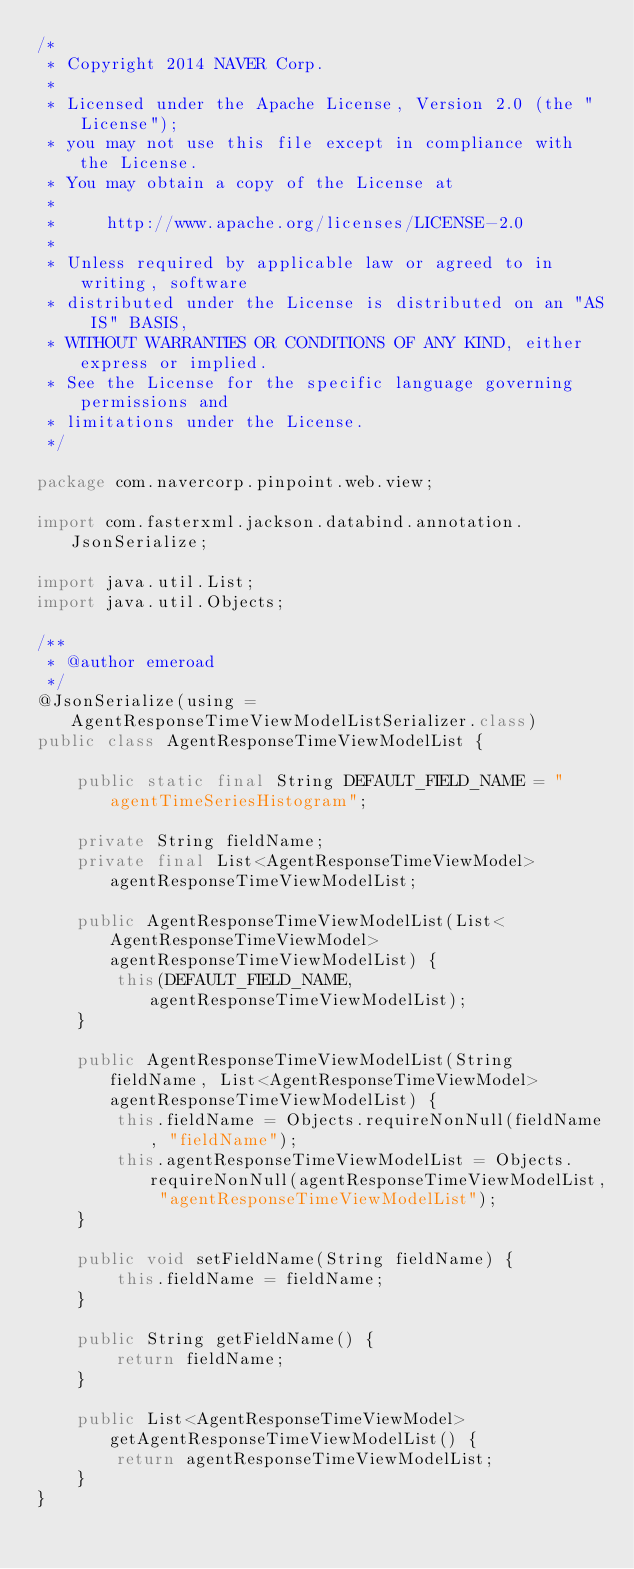Convert code to text. <code><loc_0><loc_0><loc_500><loc_500><_Java_>/*
 * Copyright 2014 NAVER Corp.
 *
 * Licensed under the Apache License, Version 2.0 (the "License");
 * you may not use this file except in compliance with the License.
 * You may obtain a copy of the License at
 *
 *     http://www.apache.org/licenses/LICENSE-2.0
 *
 * Unless required by applicable law or agreed to in writing, software
 * distributed under the License is distributed on an "AS IS" BASIS,
 * WITHOUT WARRANTIES OR CONDITIONS OF ANY KIND, either express or implied.
 * See the License for the specific language governing permissions and
 * limitations under the License.
 */

package com.navercorp.pinpoint.web.view;

import com.fasterxml.jackson.databind.annotation.JsonSerialize;

import java.util.List;
import java.util.Objects;

/**
 * @author emeroad
 */
@JsonSerialize(using = AgentResponseTimeViewModelListSerializer.class)
public class AgentResponseTimeViewModelList {

    public static final String DEFAULT_FIELD_NAME = "agentTimeSeriesHistogram";

    private String fieldName;
    private final List<AgentResponseTimeViewModel> agentResponseTimeViewModelList;

    public AgentResponseTimeViewModelList(List<AgentResponseTimeViewModel> agentResponseTimeViewModelList) {
        this(DEFAULT_FIELD_NAME, agentResponseTimeViewModelList);
    }

    public AgentResponseTimeViewModelList(String fieldName, List<AgentResponseTimeViewModel> agentResponseTimeViewModelList) {
        this.fieldName = Objects.requireNonNull(fieldName, "fieldName");
        this.agentResponseTimeViewModelList = Objects.requireNonNull(agentResponseTimeViewModelList, "agentResponseTimeViewModelList");
    }

    public void setFieldName(String fieldName) {
        this.fieldName = fieldName;
    }

    public String getFieldName() {
        return fieldName;
    }

    public List<AgentResponseTimeViewModel> getAgentResponseTimeViewModelList() {
        return agentResponseTimeViewModelList;
    }
}
</code> 